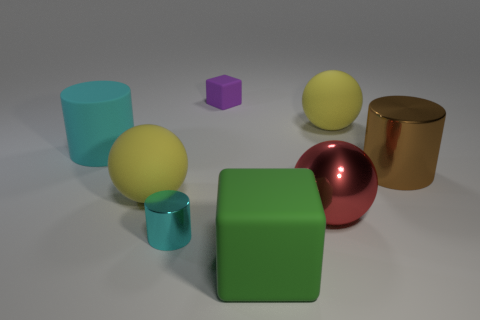There is a sphere that is in front of the big metal cylinder and right of the small cyan thing; what material is it?
Offer a terse response. Metal. Are there more big yellow balls than red metallic spheres?
Ensure brevity in your answer.  Yes. There is a block behind the thing that is to the left of the yellow rubber object on the left side of the green cube; what is its color?
Provide a short and direct response. Purple. Does the big yellow sphere that is to the right of the small purple matte cube have the same material as the tiny cyan thing?
Give a very brief answer. No. Are there any metallic balls that have the same color as the small matte object?
Give a very brief answer. No. Are any tiny yellow matte objects visible?
Provide a short and direct response. No. Does the block that is behind the red sphere have the same size as the big cyan cylinder?
Your answer should be very brief. No. Are there fewer big things than brown metal things?
Your answer should be very brief. No. There is a small thing in front of the yellow matte sphere on the left side of the rubber object right of the big green matte thing; what shape is it?
Offer a terse response. Cylinder. Is there a big purple sphere that has the same material as the small purple cube?
Offer a terse response. No. 